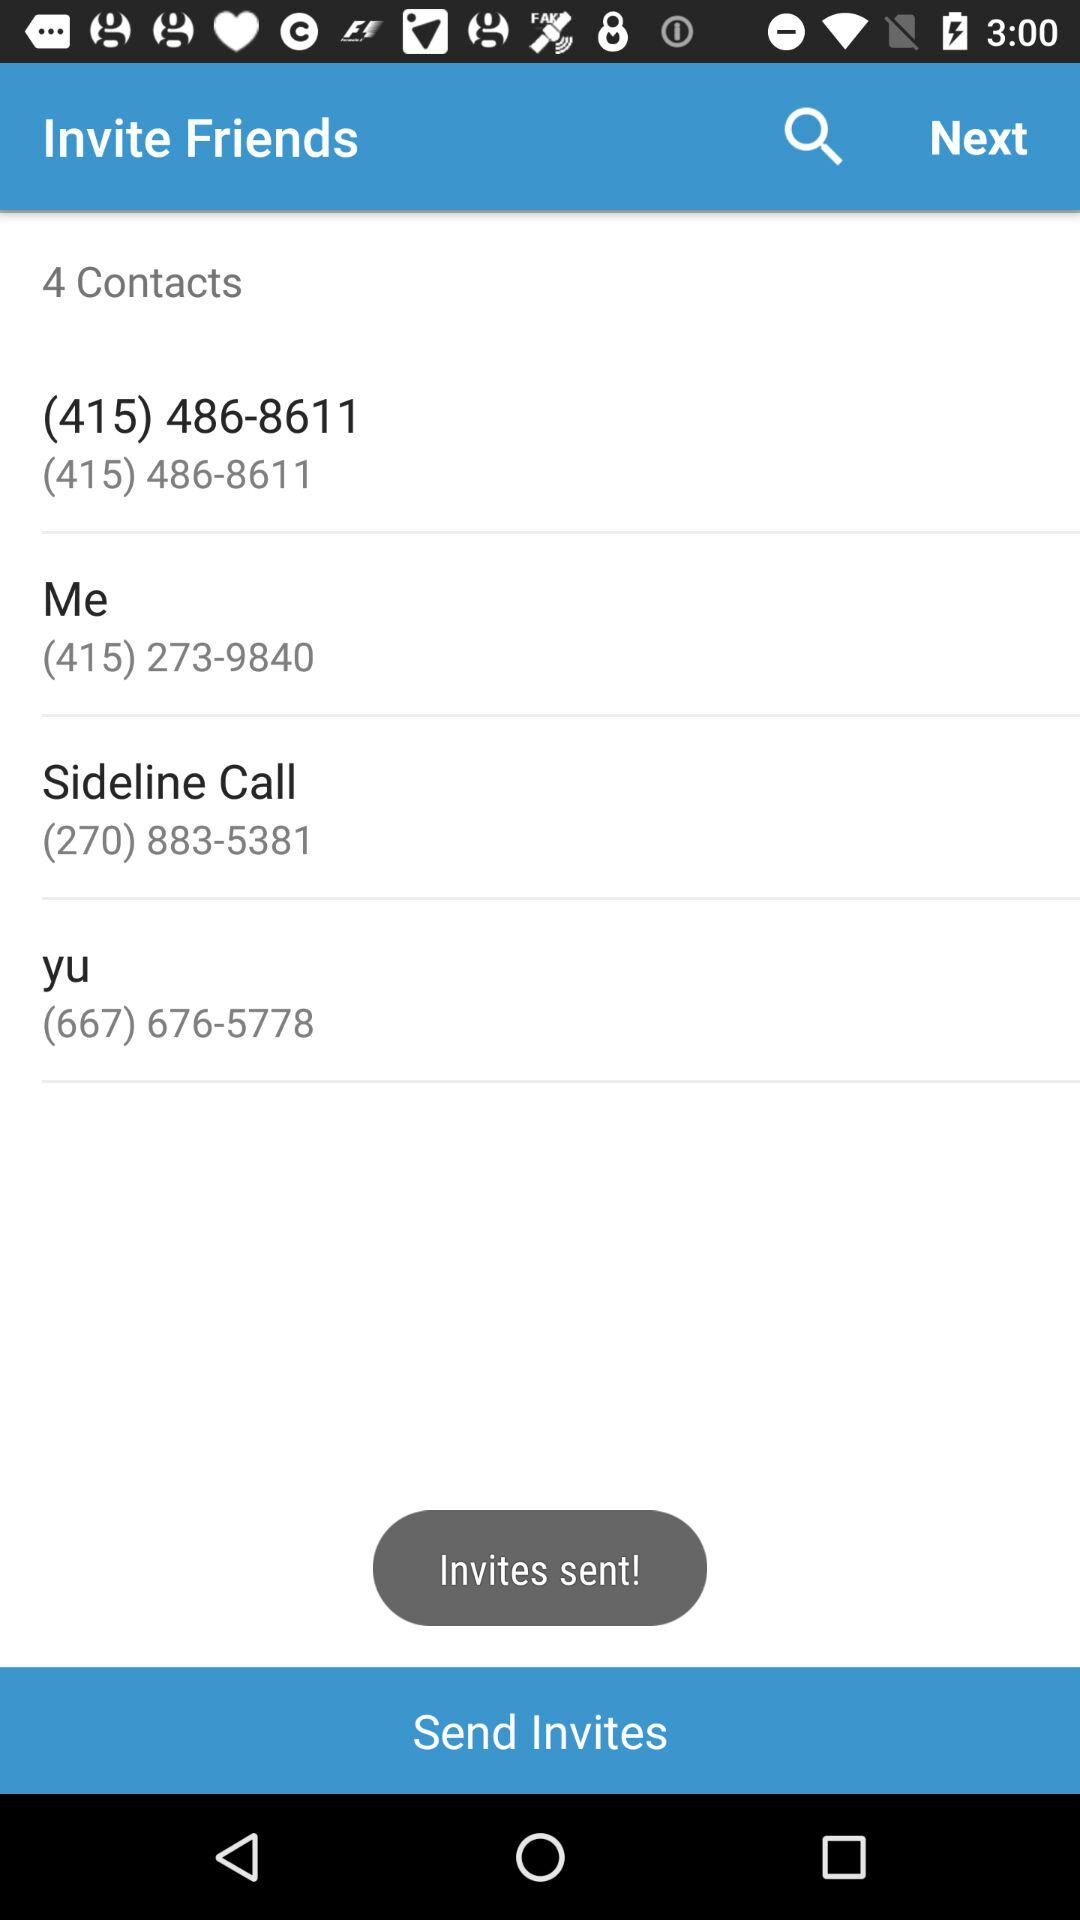What is the contact number ending with 8611? The contact number ending with 8611 is (415) 486-8611. 